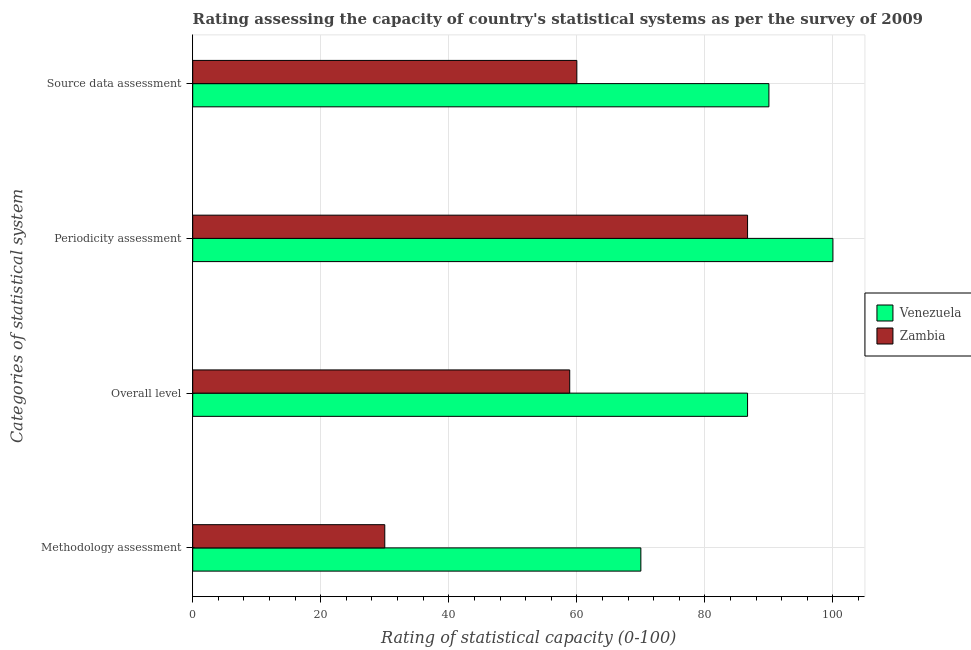How many groups of bars are there?
Ensure brevity in your answer.  4. Are the number of bars per tick equal to the number of legend labels?
Provide a short and direct response. Yes. What is the label of the 3rd group of bars from the top?
Ensure brevity in your answer.  Overall level. What is the overall level rating in Venezuela?
Provide a succinct answer. 86.67. Across all countries, what is the maximum overall level rating?
Your answer should be very brief. 86.67. Across all countries, what is the minimum methodology assessment rating?
Keep it short and to the point. 30. In which country was the periodicity assessment rating maximum?
Provide a succinct answer. Venezuela. In which country was the source data assessment rating minimum?
Give a very brief answer. Zambia. What is the total periodicity assessment rating in the graph?
Your answer should be very brief. 186.67. What is the difference between the methodology assessment rating in Zambia and that in Venezuela?
Your answer should be compact. -40. What is the difference between the overall level rating in Zambia and the source data assessment rating in Venezuela?
Make the answer very short. -31.11. What is the average overall level rating per country?
Your answer should be very brief. 72.78. What is the difference between the source data assessment rating and methodology assessment rating in Zambia?
Make the answer very short. 30. In how many countries, is the periodicity assessment rating greater than 60 ?
Your answer should be compact. 2. What is the ratio of the periodicity assessment rating in Zambia to that in Venezuela?
Ensure brevity in your answer.  0.87. Is the overall level rating in Zambia less than that in Venezuela?
Provide a succinct answer. Yes. What is the difference between the highest and the lowest methodology assessment rating?
Offer a terse response. 40. Is the sum of the overall level rating in Zambia and Venezuela greater than the maximum methodology assessment rating across all countries?
Ensure brevity in your answer.  Yes. Is it the case that in every country, the sum of the source data assessment rating and periodicity assessment rating is greater than the sum of methodology assessment rating and overall level rating?
Ensure brevity in your answer.  Yes. What does the 1st bar from the top in Overall level represents?
Offer a terse response. Zambia. What does the 1st bar from the bottom in Overall level represents?
Offer a terse response. Venezuela. How many bars are there?
Make the answer very short. 8. Are all the bars in the graph horizontal?
Provide a succinct answer. Yes. How many countries are there in the graph?
Keep it short and to the point. 2. What is the difference between two consecutive major ticks on the X-axis?
Your answer should be very brief. 20. Does the graph contain grids?
Keep it short and to the point. Yes. Where does the legend appear in the graph?
Give a very brief answer. Center right. How many legend labels are there?
Ensure brevity in your answer.  2. How are the legend labels stacked?
Your answer should be compact. Vertical. What is the title of the graph?
Make the answer very short. Rating assessing the capacity of country's statistical systems as per the survey of 2009 . What is the label or title of the X-axis?
Your answer should be compact. Rating of statistical capacity (0-100). What is the label or title of the Y-axis?
Give a very brief answer. Categories of statistical system. What is the Rating of statistical capacity (0-100) in Zambia in Methodology assessment?
Your response must be concise. 30. What is the Rating of statistical capacity (0-100) of Venezuela in Overall level?
Your response must be concise. 86.67. What is the Rating of statistical capacity (0-100) of Zambia in Overall level?
Offer a terse response. 58.89. What is the Rating of statistical capacity (0-100) in Venezuela in Periodicity assessment?
Give a very brief answer. 100. What is the Rating of statistical capacity (0-100) in Zambia in Periodicity assessment?
Your answer should be compact. 86.67. What is the Rating of statistical capacity (0-100) of Venezuela in Source data assessment?
Provide a short and direct response. 90. What is the Rating of statistical capacity (0-100) of Zambia in Source data assessment?
Your response must be concise. 60. Across all Categories of statistical system, what is the maximum Rating of statistical capacity (0-100) of Zambia?
Your answer should be very brief. 86.67. Across all Categories of statistical system, what is the minimum Rating of statistical capacity (0-100) of Zambia?
Your answer should be compact. 30. What is the total Rating of statistical capacity (0-100) in Venezuela in the graph?
Your answer should be very brief. 346.67. What is the total Rating of statistical capacity (0-100) of Zambia in the graph?
Your response must be concise. 235.56. What is the difference between the Rating of statistical capacity (0-100) of Venezuela in Methodology assessment and that in Overall level?
Offer a terse response. -16.67. What is the difference between the Rating of statistical capacity (0-100) of Zambia in Methodology assessment and that in Overall level?
Provide a short and direct response. -28.89. What is the difference between the Rating of statistical capacity (0-100) in Zambia in Methodology assessment and that in Periodicity assessment?
Your answer should be very brief. -56.67. What is the difference between the Rating of statistical capacity (0-100) in Venezuela in Overall level and that in Periodicity assessment?
Ensure brevity in your answer.  -13.33. What is the difference between the Rating of statistical capacity (0-100) in Zambia in Overall level and that in Periodicity assessment?
Your answer should be compact. -27.78. What is the difference between the Rating of statistical capacity (0-100) in Zambia in Overall level and that in Source data assessment?
Ensure brevity in your answer.  -1.11. What is the difference between the Rating of statistical capacity (0-100) of Zambia in Periodicity assessment and that in Source data assessment?
Provide a short and direct response. 26.67. What is the difference between the Rating of statistical capacity (0-100) of Venezuela in Methodology assessment and the Rating of statistical capacity (0-100) of Zambia in Overall level?
Provide a short and direct response. 11.11. What is the difference between the Rating of statistical capacity (0-100) in Venezuela in Methodology assessment and the Rating of statistical capacity (0-100) in Zambia in Periodicity assessment?
Your answer should be compact. -16.67. What is the difference between the Rating of statistical capacity (0-100) in Venezuela in Methodology assessment and the Rating of statistical capacity (0-100) in Zambia in Source data assessment?
Provide a short and direct response. 10. What is the difference between the Rating of statistical capacity (0-100) of Venezuela in Overall level and the Rating of statistical capacity (0-100) of Zambia in Source data assessment?
Offer a terse response. 26.67. What is the average Rating of statistical capacity (0-100) in Venezuela per Categories of statistical system?
Give a very brief answer. 86.67. What is the average Rating of statistical capacity (0-100) in Zambia per Categories of statistical system?
Give a very brief answer. 58.89. What is the difference between the Rating of statistical capacity (0-100) of Venezuela and Rating of statistical capacity (0-100) of Zambia in Overall level?
Offer a terse response. 27.78. What is the difference between the Rating of statistical capacity (0-100) in Venezuela and Rating of statistical capacity (0-100) in Zambia in Periodicity assessment?
Keep it short and to the point. 13.33. What is the difference between the Rating of statistical capacity (0-100) in Venezuela and Rating of statistical capacity (0-100) in Zambia in Source data assessment?
Your response must be concise. 30. What is the ratio of the Rating of statistical capacity (0-100) of Venezuela in Methodology assessment to that in Overall level?
Offer a very short reply. 0.81. What is the ratio of the Rating of statistical capacity (0-100) of Zambia in Methodology assessment to that in Overall level?
Keep it short and to the point. 0.51. What is the ratio of the Rating of statistical capacity (0-100) of Zambia in Methodology assessment to that in Periodicity assessment?
Offer a very short reply. 0.35. What is the ratio of the Rating of statistical capacity (0-100) of Zambia in Methodology assessment to that in Source data assessment?
Keep it short and to the point. 0.5. What is the ratio of the Rating of statistical capacity (0-100) in Venezuela in Overall level to that in Periodicity assessment?
Provide a short and direct response. 0.87. What is the ratio of the Rating of statistical capacity (0-100) in Zambia in Overall level to that in Periodicity assessment?
Keep it short and to the point. 0.68. What is the ratio of the Rating of statistical capacity (0-100) in Venezuela in Overall level to that in Source data assessment?
Make the answer very short. 0.96. What is the ratio of the Rating of statistical capacity (0-100) of Zambia in Overall level to that in Source data assessment?
Give a very brief answer. 0.98. What is the ratio of the Rating of statistical capacity (0-100) in Zambia in Periodicity assessment to that in Source data assessment?
Your answer should be very brief. 1.44. What is the difference between the highest and the second highest Rating of statistical capacity (0-100) in Venezuela?
Your answer should be very brief. 10. What is the difference between the highest and the second highest Rating of statistical capacity (0-100) in Zambia?
Your answer should be very brief. 26.67. What is the difference between the highest and the lowest Rating of statistical capacity (0-100) of Zambia?
Your answer should be compact. 56.67. 